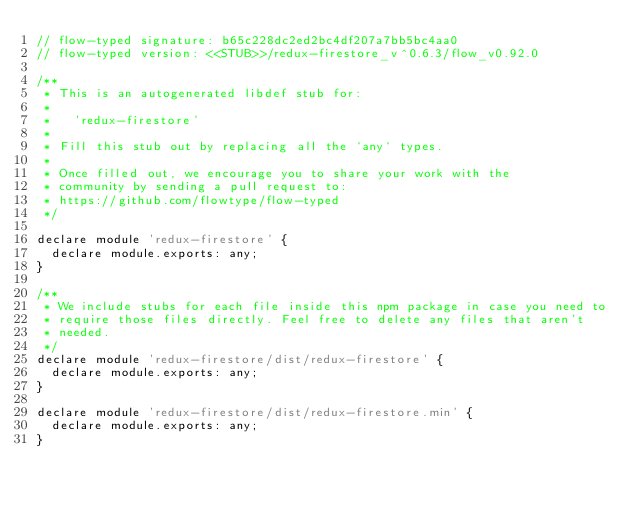<code> <loc_0><loc_0><loc_500><loc_500><_JavaScript_>// flow-typed signature: b65c228dc2ed2bc4df207a7bb5bc4aa0
// flow-typed version: <<STUB>>/redux-firestore_v^0.6.3/flow_v0.92.0

/**
 * This is an autogenerated libdef stub for:
 *
 *   'redux-firestore'
 *
 * Fill this stub out by replacing all the `any` types.
 *
 * Once filled out, we encourage you to share your work with the
 * community by sending a pull request to:
 * https://github.com/flowtype/flow-typed
 */

declare module 'redux-firestore' {
  declare module.exports: any;
}

/**
 * We include stubs for each file inside this npm package in case you need to
 * require those files directly. Feel free to delete any files that aren't
 * needed.
 */
declare module 'redux-firestore/dist/redux-firestore' {
  declare module.exports: any;
}

declare module 'redux-firestore/dist/redux-firestore.min' {
  declare module.exports: any;
}
</code> 